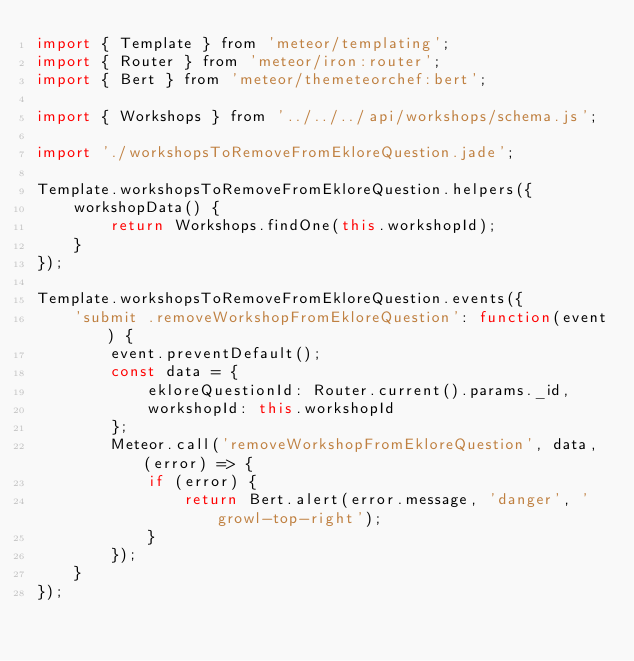<code> <loc_0><loc_0><loc_500><loc_500><_JavaScript_>import { Template } from 'meteor/templating';
import { Router } from 'meteor/iron:router';
import { Bert } from 'meteor/themeteorchef:bert';

import { Workshops } from '../../../api/workshops/schema.js';

import './workshopsToRemoveFromEkloreQuestion.jade';

Template.workshopsToRemoveFromEkloreQuestion.helpers({
	workshopData() {
		return Workshops.findOne(this.workshopId);
	}
});

Template.workshopsToRemoveFromEkloreQuestion.events({
	'submit .removeWorkshopFromEkloreQuestion': function(event) {
		event.preventDefault();
		const data = {
			ekloreQuestionId: Router.current().params._id,
			workshopId: this.workshopId
		};
		Meteor.call('removeWorkshopFromEkloreQuestion', data, (error) => {
			if (error) {
				return Bert.alert(error.message, 'danger', 'growl-top-right');
			}
		});
	}
});
</code> 